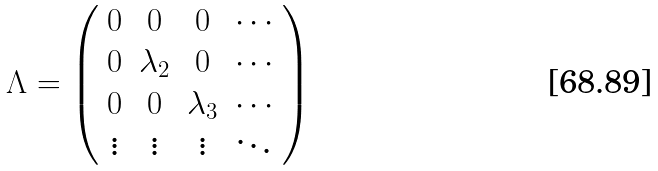<formula> <loc_0><loc_0><loc_500><loc_500>\Lambda = \left ( \begin{array} { c c c c } 0 & 0 & 0 & \cdots \\ 0 & \lambda _ { 2 } & 0 & \cdots \\ 0 & 0 & \lambda _ { 3 } & \cdots \\ \vdots & \vdots & \vdots & \ddots \end{array} \right )</formula> 